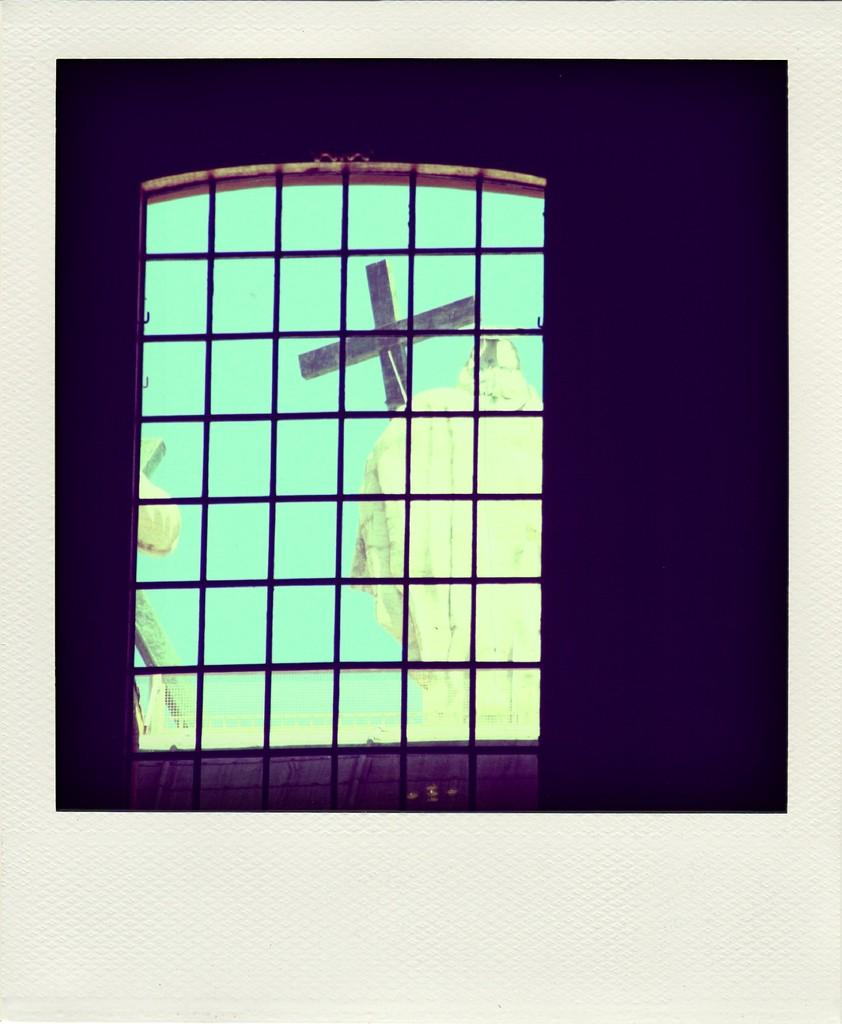What type of window is present in the image? There is a grille window in the image. What can be seen through the grille window? A cross symbol is visible through the grille window. What is visible in the background of the image? The sky is visible in the image. Are there any objects visible in the image? Yes, there are objects visible in the image. How are the borders of the image presented? The image has white color borders. What type of spoon is shown in the image? There is no spoon present in the image. What season is depicted in the image? The image does not depict a specific season, as there is no indication of weather or seasonal elements. 